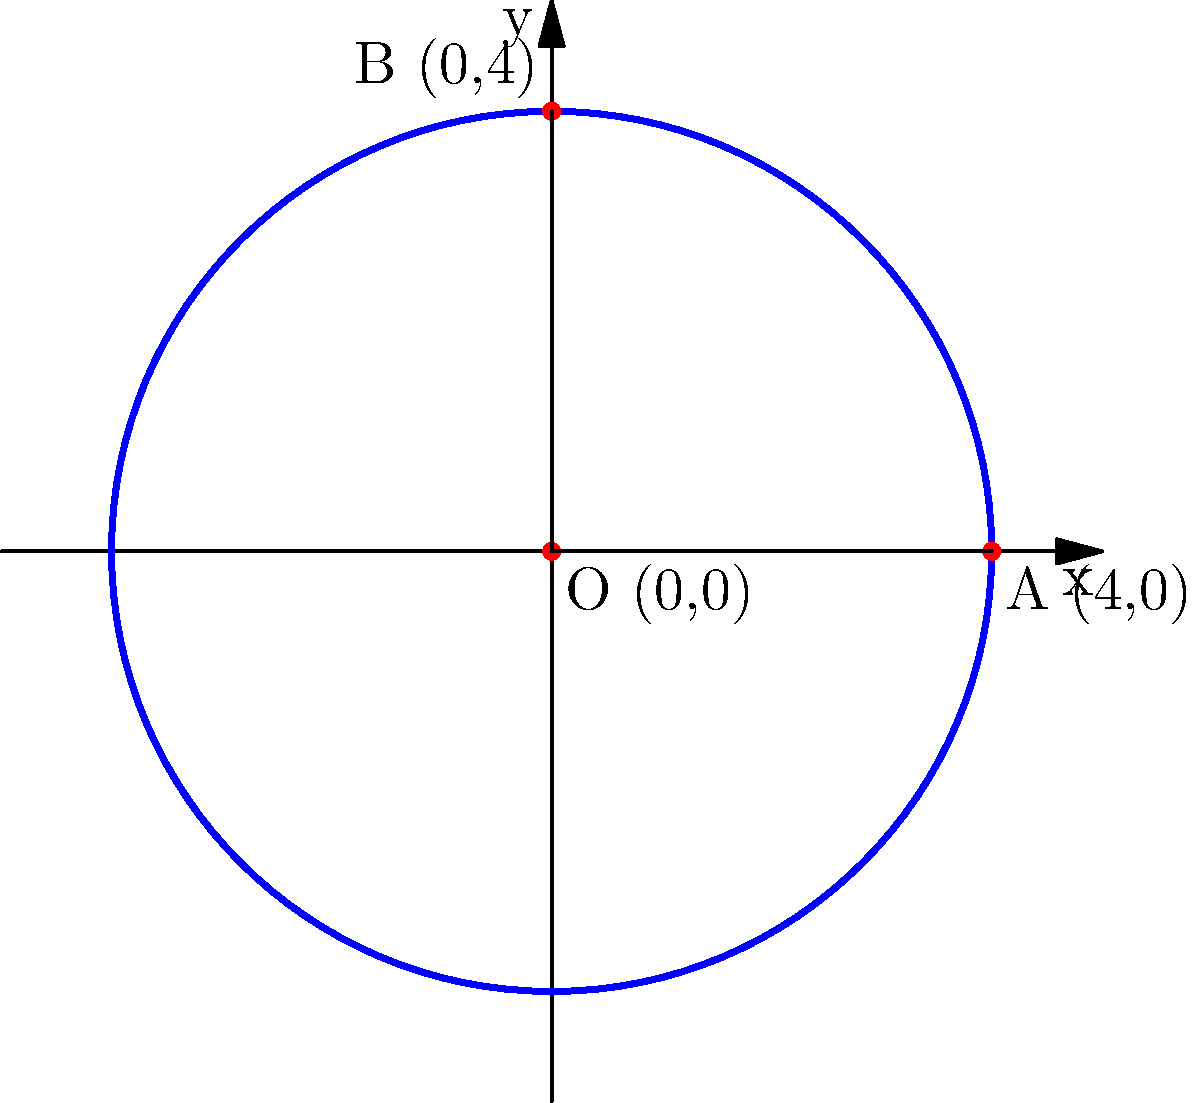In the cosmic dance of geometry, a sacred mandala is represented by a circle on the coordinate plane. The center of this spiritual circle lies at the origin (0,0), and it passes through the points A(4,0) and B(0,4). Calculate the area of this mandala, understanding that its measurement transcends the physical realm and touches the very essence of universal harmony. To find the area of this mandala, we shall follow these spiritual steps:

1) First, we must understand that the radius of the circle is key to unlocking its area. We can find this by examining the distance from the center to either point A or B.

2) Using the Pythagorean theorem, we can calculate the radius:
   $r^2 = 4^2 + 0^2 = 16$
   $r = 4$

3) Now, we recall the sacred formula for the area of a circle:
   $A = \pi r^2$

4) Substituting our radius:
   $A = \pi (4)^2 = 16\pi$

5) In the language of mathematics, we express this as:
   $A = 16\pi$ square units

6) This area represents the expanse of our mandala, a symbol of the universe's infinite nature contained within a finite form.
Answer: $16\pi$ square units 